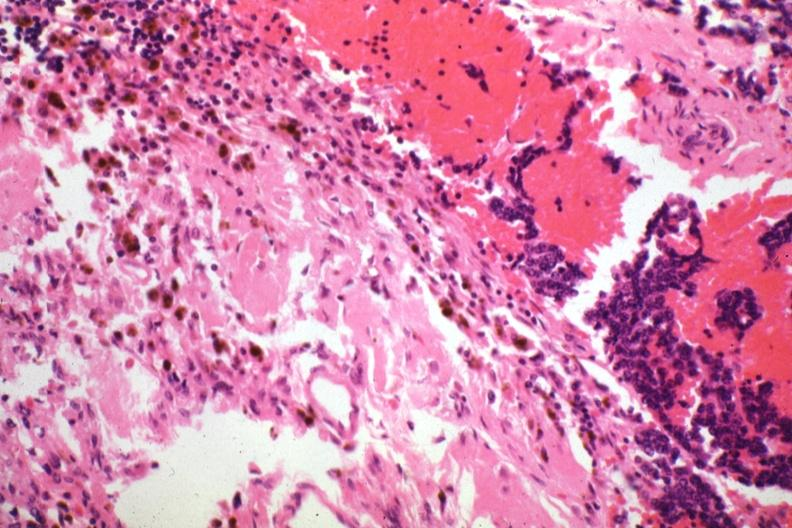s vessel present?
Answer the question using a single word or phrase. No 